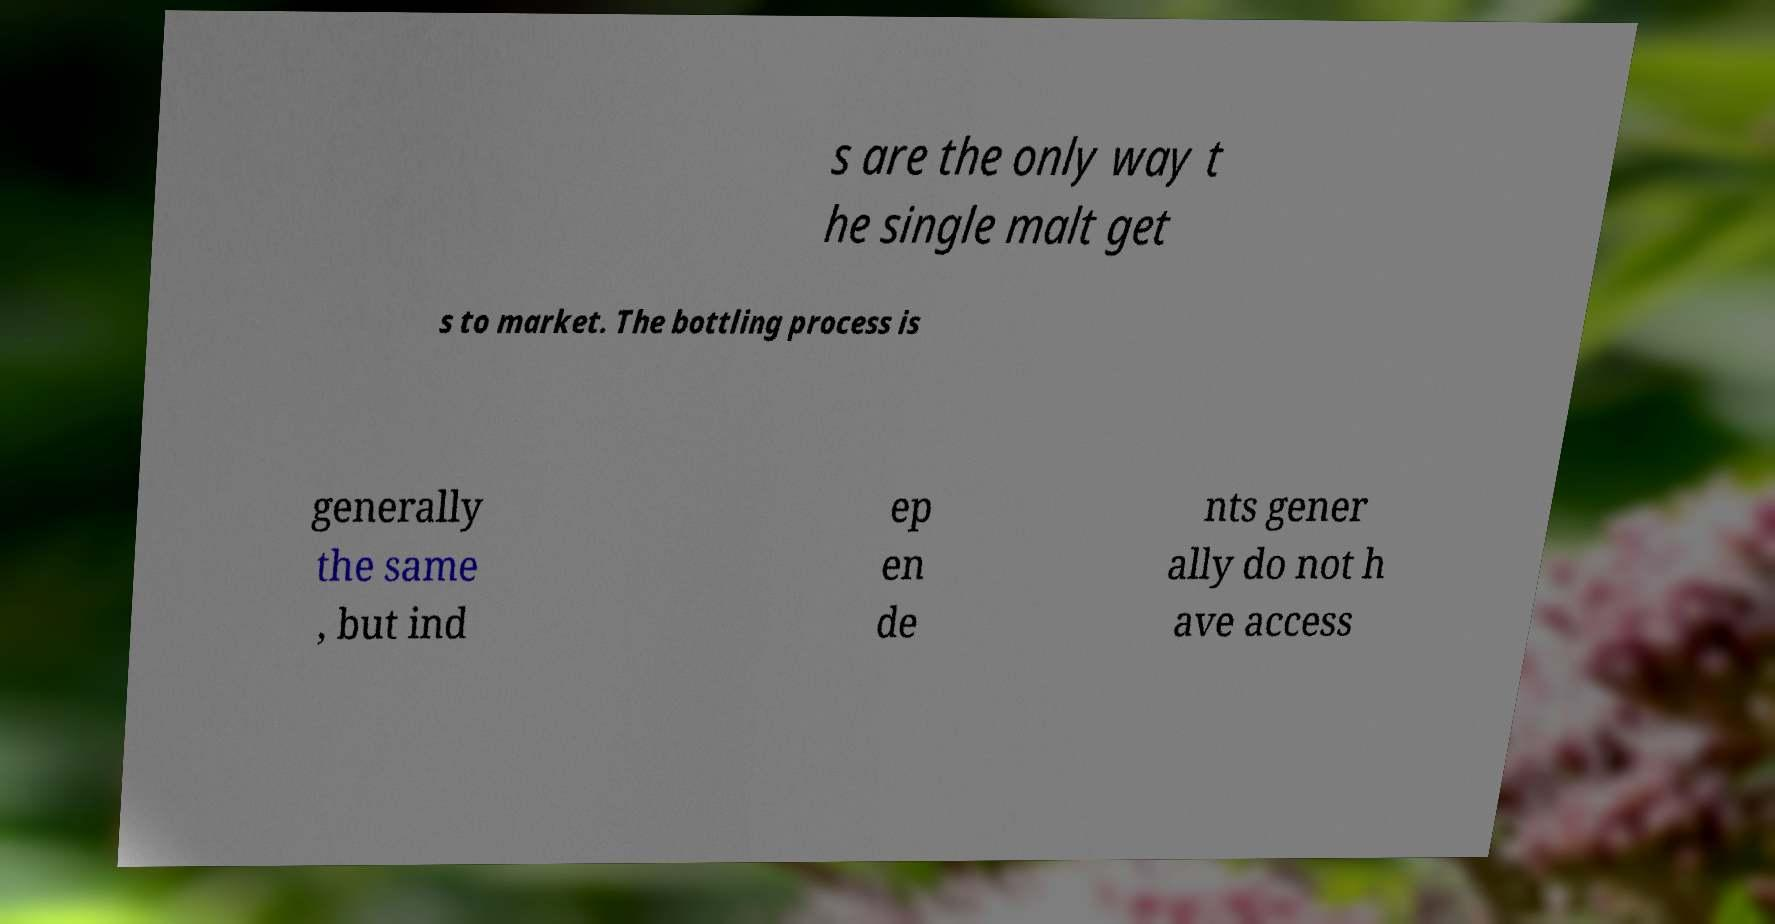For documentation purposes, I need the text within this image transcribed. Could you provide that? s are the only way t he single malt get s to market. The bottling process is generally the same , but ind ep en de nts gener ally do not h ave access 